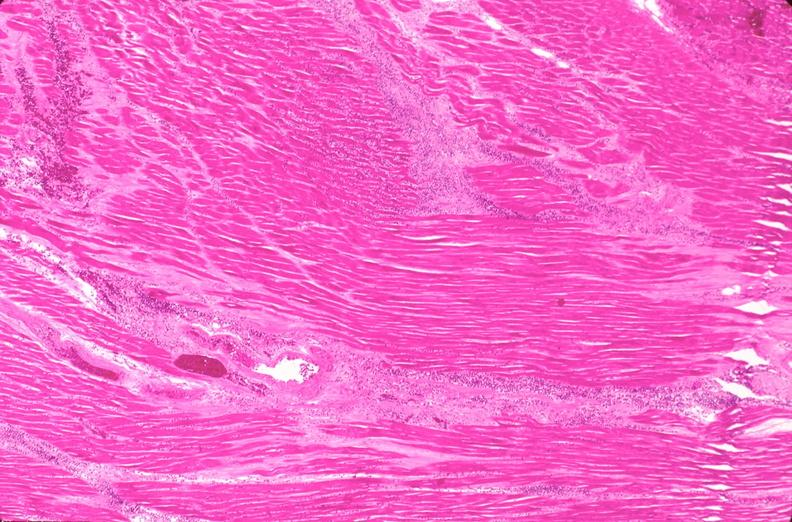what does this image show?
Answer the question using a single word or phrase. Heart 